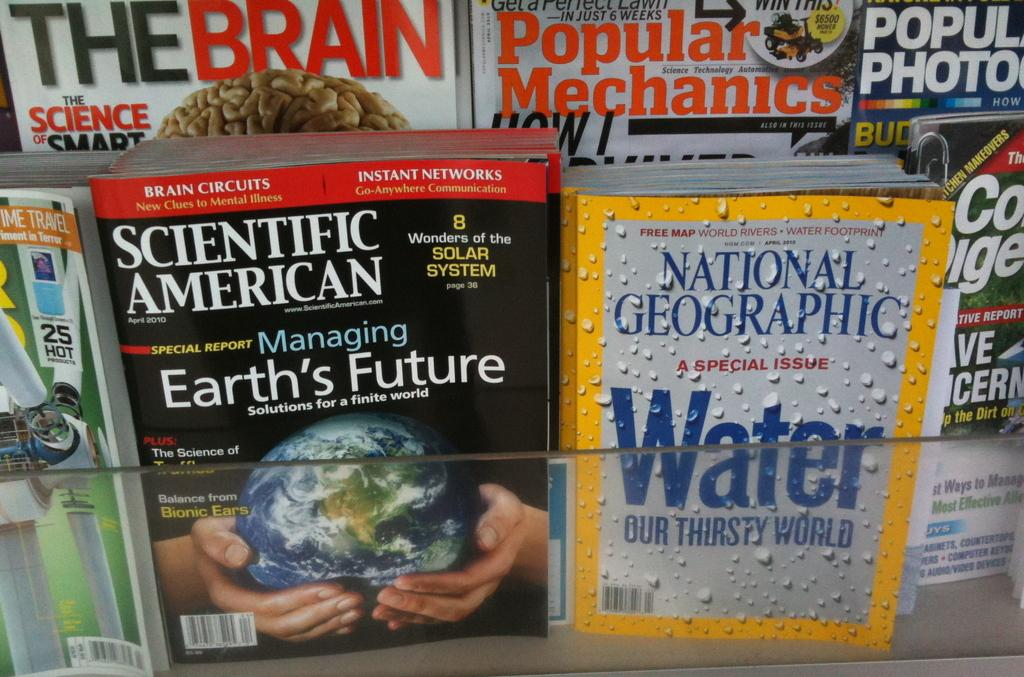<image>
Render a clear and concise summary of the photo. A bunch of magazines are displayed such as Scientific American and National Geographic. 